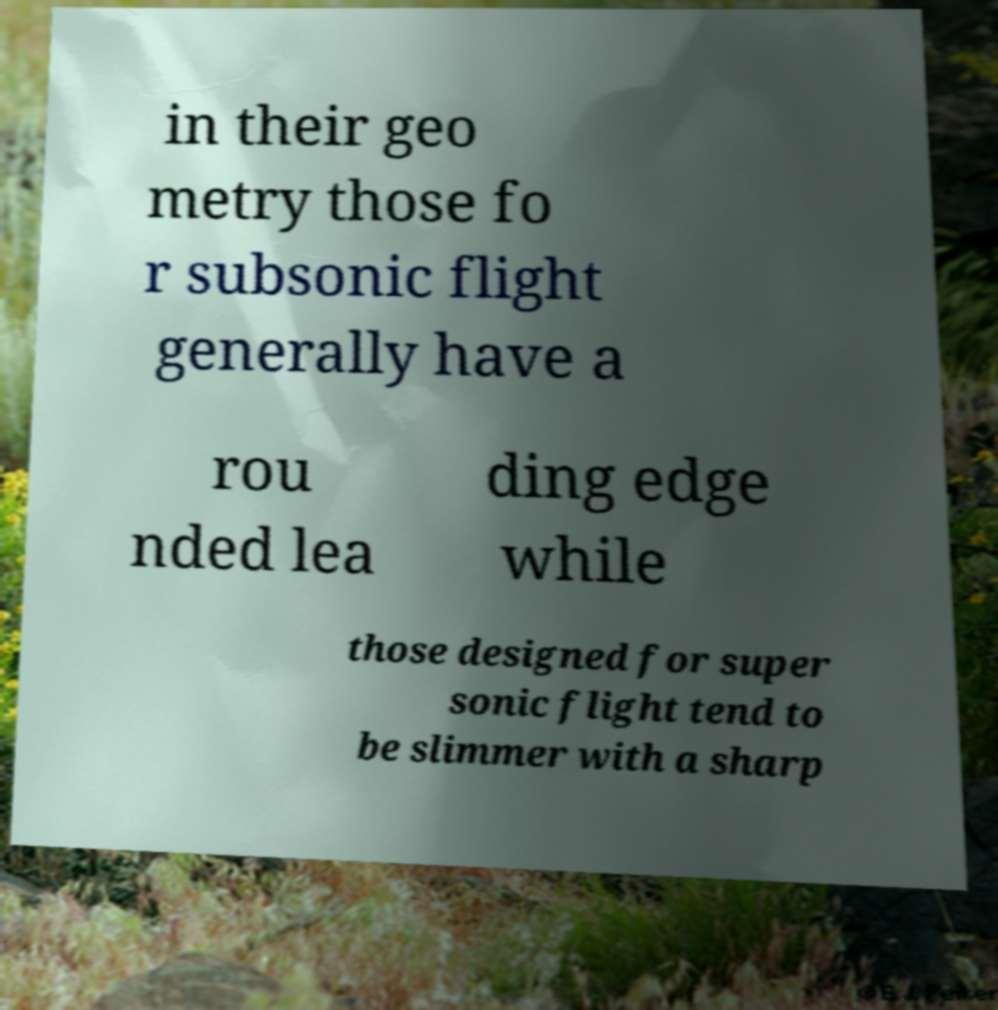Could you extract and type out the text from this image? in their geo metry those fo r subsonic flight generally have a rou nded lea ding edge while those designed for super sonic flight tend to be slimmer with a sharp 